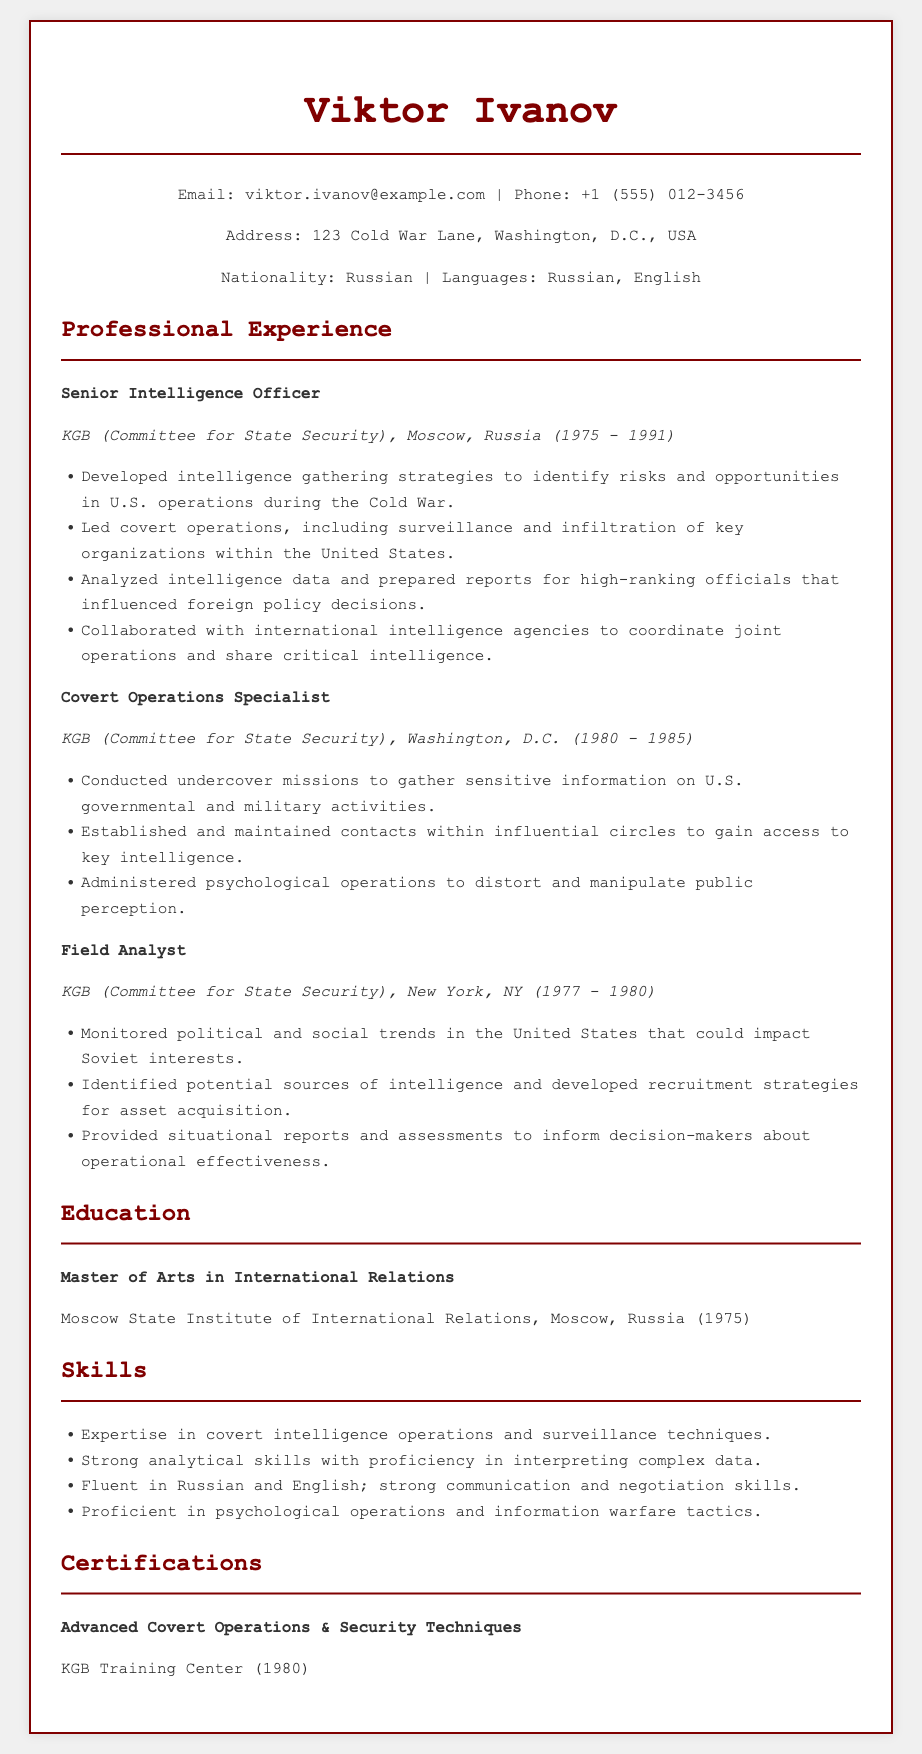What was Viktor Ivanov's role from 1975 to 1991? Viktor Ivanov served as a Senior Intelligence Officer at the KGB from 1975 to 1991.
Answer: Senior Intelligence Officer Where did Viktor Ivanov work between 1980 and 1985? Between 1980 and 1985, Viktor Ivanov worked in Washington, D.C. as a Covert Operations Specialist.
Answer: Washington, D.C What year did Viktor Ivanov complete his Master's degree? Viktor Ivanov completed his Master's degree in 1975.
Answer: 1975 How long did Viktor Ivanov serve as a Field Analyst? Viktor Ivanov worked as a Field Analyst from 1977 to 1980, which is a total of 3 years.
Answer: 3 years What is one of Viktor Ivanov's skills? One of Viktor Ivanov's skills is expertise in covert intelligence operations and surveillance techniques.
Answer: Covert intelligence operations What certification did Viktor Ivanov receive and from where? Viktor Ivanov received certification in Advanced Covert Operations & Security Techniques from the KGB Training Center.
Answer: KGB Training Center What type of missions did Viktor Ivanov conduct as a Covert Operations Specialist? As a Covert Operations Specialist, Viktor Ivanov conducted undercover missions.
Answer: Undercover missions What was the primary focus of Viktor Ivanov's work as a Senior Intelligence Officer? The primary focus was to develop intelligence gathering strategies related to U.S. operations during the Cold War.
Answer: Intelligence gathering strategies How many languages does Viktor Ivanov speak? Viktor Ivanov speaks two languages: Russian and English.
Answer: Two languages 